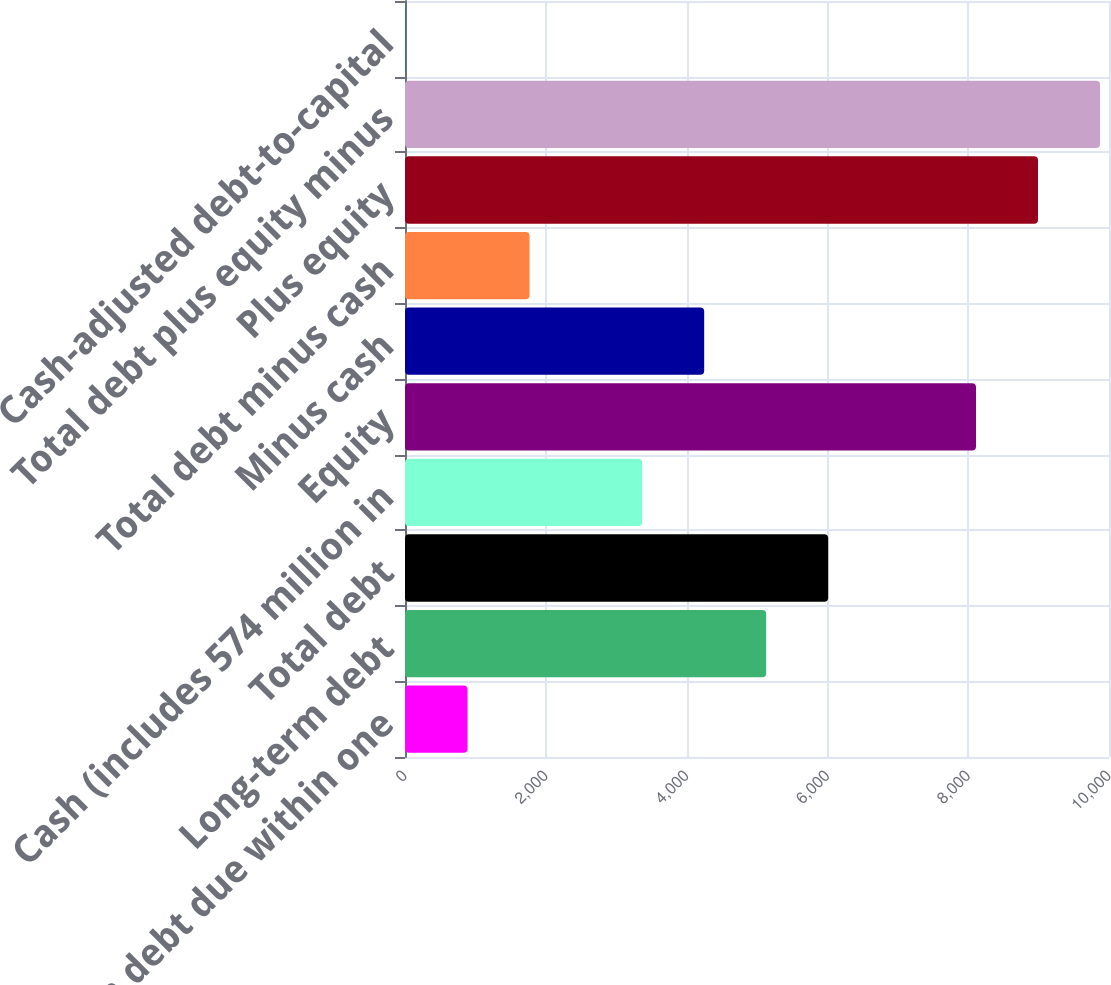Convert chart. <chart><loc_0><loc_0><loc_500><loc_500><bar_chart><fcel>Long-term debt due within one<fcel>Long-term debt<fcel>Total debt<fcel>Cash (includes 574 million in<fcel>Equity<fcel>Minus cash<fcel>Total debt minus cash<fcel>Plus equity<fcel>Total debt plus equity minus<fcel>Cash-adjusted debt-to-capital<nl><fcel>888.7<fcel>5130.4<fcel>6011.1<fcel>3369<fcel>8111<fcel>4249.7<fcel>1769.4<fcel>8991.7<fcel>9872.4<fcel>8<nl></chart> 